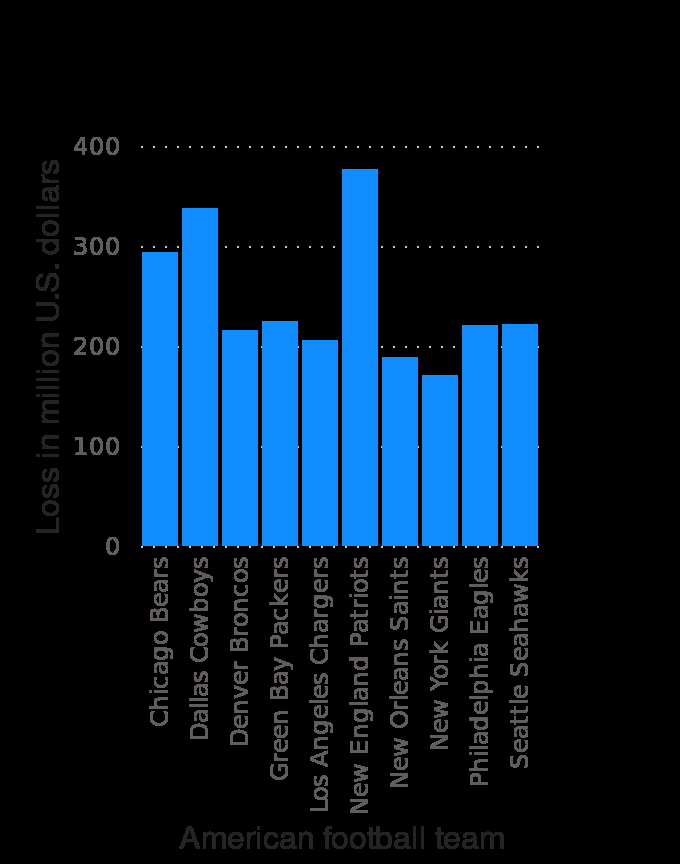<image>
Is there any football team that hasn't lost any money?  No, every football team has lost money. What does the y-axis represent in the bar plot? The y-axis represents the loss in million U.S. dollars. What is the title of the bar plot? The title of the bar plot is "Potential ticket revenue loss in the NFL due to the coronavirus (COVID-19) pandemic in the United States in 2020, by team (in million U.S. dollars)". What does the bar plot depict? The bar plot depicts the potential ticket revenue loss in the NFL in 2020, caused by the coronavirus (COVID-19) pandemic, for each American football team in the United States. 